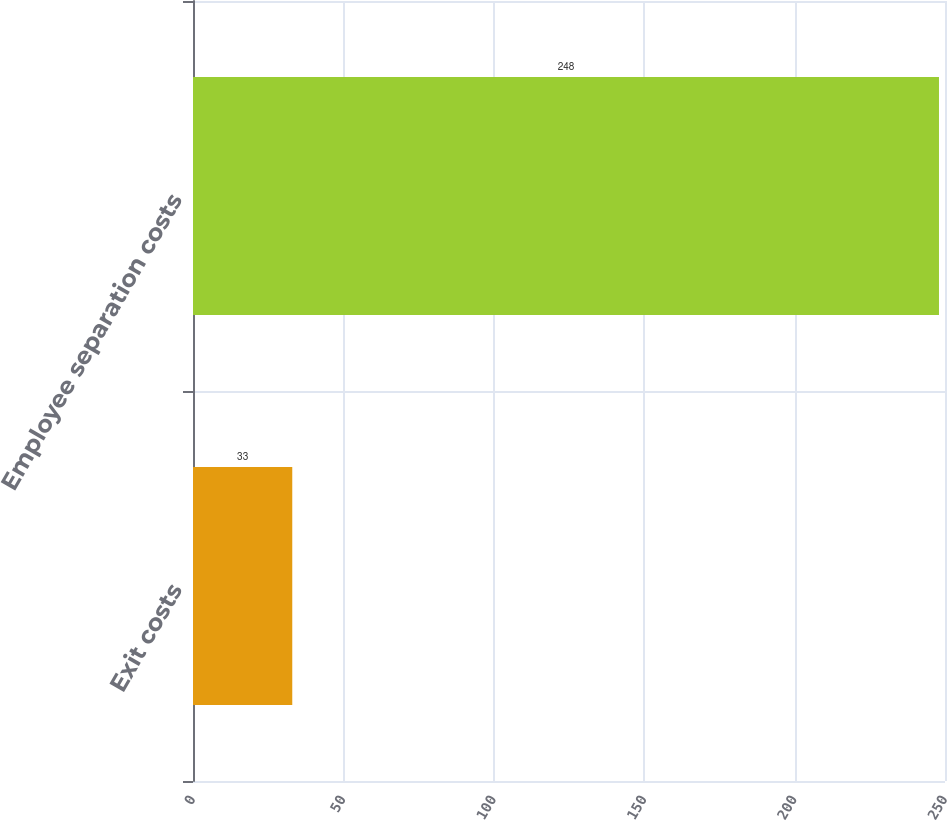<chart> <loc_0><loc_0><loc_500><loc_500><bar_chart><fcel>Exit costs<fcel>Employee separation costs<nl><fcel>33<fcel>248<nl></chart> 